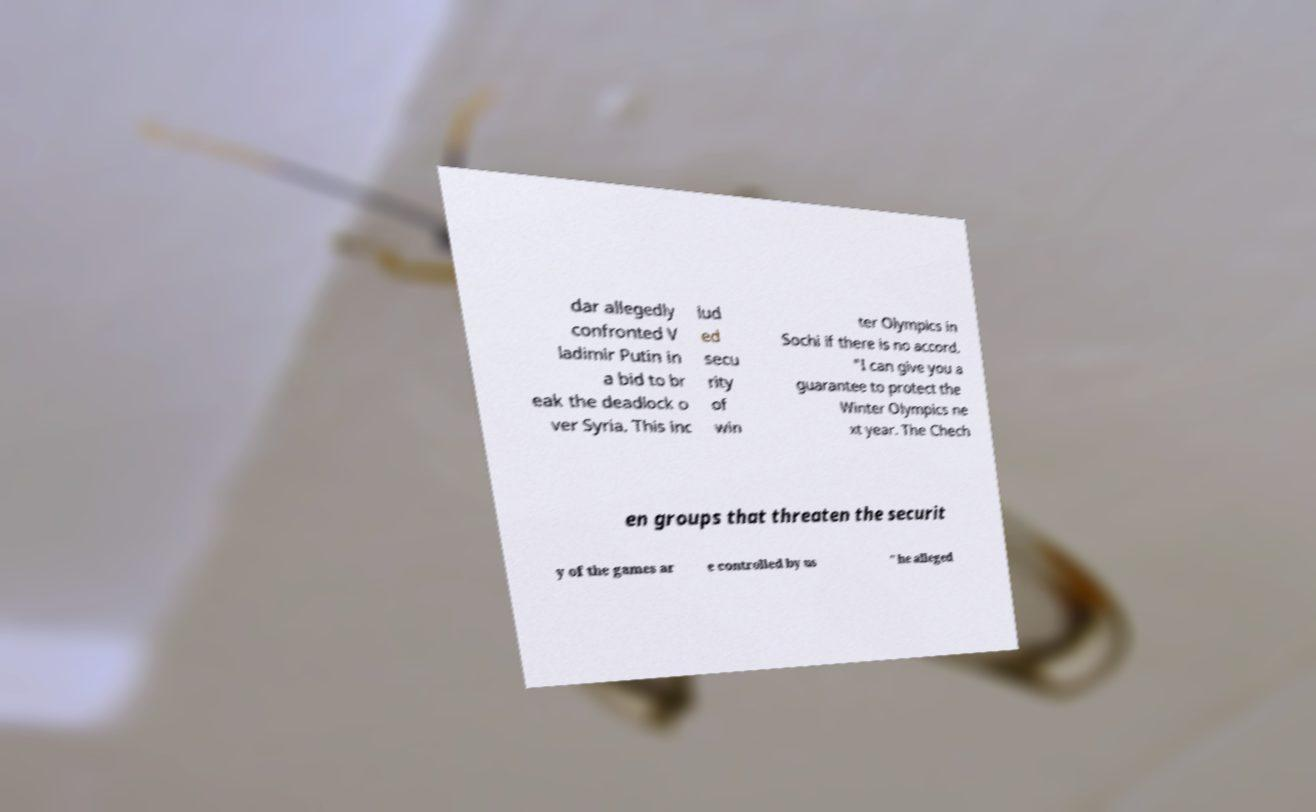Please identify and transcribe the text found in this image. dar allegedly confronted V ladimir Putin in a bid to br eak the deadlock o ver Syria. This inc lud ed secu rity of win ter Olympics in Sochi if there is no accord. "I can give you a guarantee to protect the Winter Olympics ne xt year. The Chech en groups that threaten the securit y of the games ar e controlled by us " he alleged 